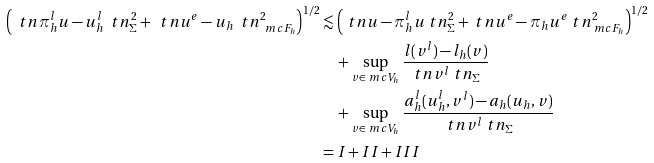<formula> <loc_0><loc_0><loc_500><loc_500>\left ( \ t n \pi _ { h } ^ { l } u - u _ { h } ^ { l } \ t n ^ { 2 } _ { \Sigma } + \ t n u ^ { e } - u _ { h } \ t n ^ { 2 } _ { \ m c F _ { h } } \right ) ^ { 1 / 2 } & \lesssim \left ( \ t n u - \pi _ { h } ^ { l } u \ t n ^ { 2 } _ { \Sigma } + \ t n u ^ { e } - \pi _ { h } u ^ { e } \ t n ^ { 2 } _ { \ m c F _ { h } } \right ) ^ { 1 / 2 } \\ & \quad + \sup _ { v \in \ m c V _ { h } } \frac { l ( v ^ { l } ) - l _ { h } ( v ) } { \ t n v ^ { l } \ t n _ { \Sigma } } \\ & \quad + \sup _ { v \in \ m c V _ { h } } \frac { a _ { h } ^ { l } ( u _ { h } ^ { l } , v ^ { l } ) - a _ { h } ( u _ { h } , v ) } { \ t n v ^ { l } \ t n _ { \Sigma } } \\ & = I + I I + I I I</formula> 